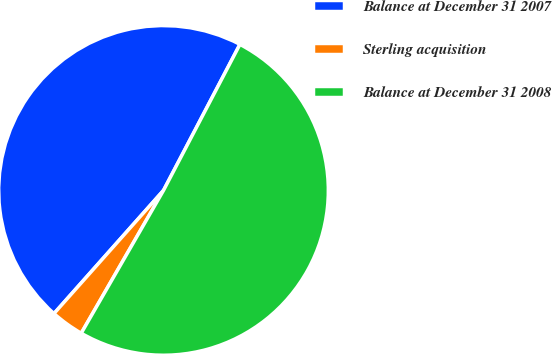Convert chart to OTSL. <chart><loc_0><loc_0><loc_500><loc_500><pie_chart><fcel>Balance at December 31 2007<fcel>Sterling acquisition<fcel>Balance at December 31 2008<nl><fcel>46.1%<fcel>3.25%<fcel>50.64%<nl></chart> 